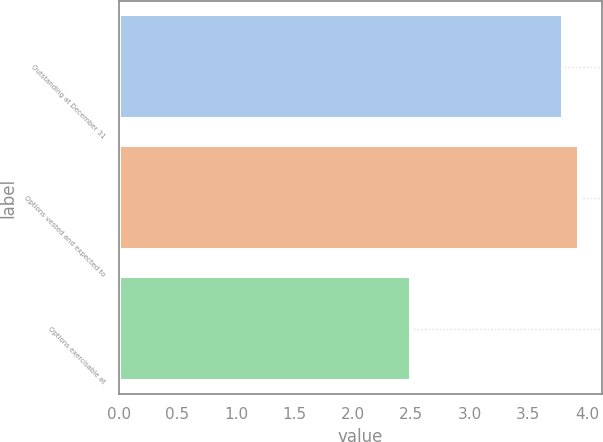<chart> <loc_0><loc_0><loc_500><loc_500><bar_chart><fcel>Outstanding at December 31<fcel>Options vested and expected to<fcel>Options exercisable at<nl><fcel>3.8<fcel>3.93<fcel>2.5<nl></chart> 